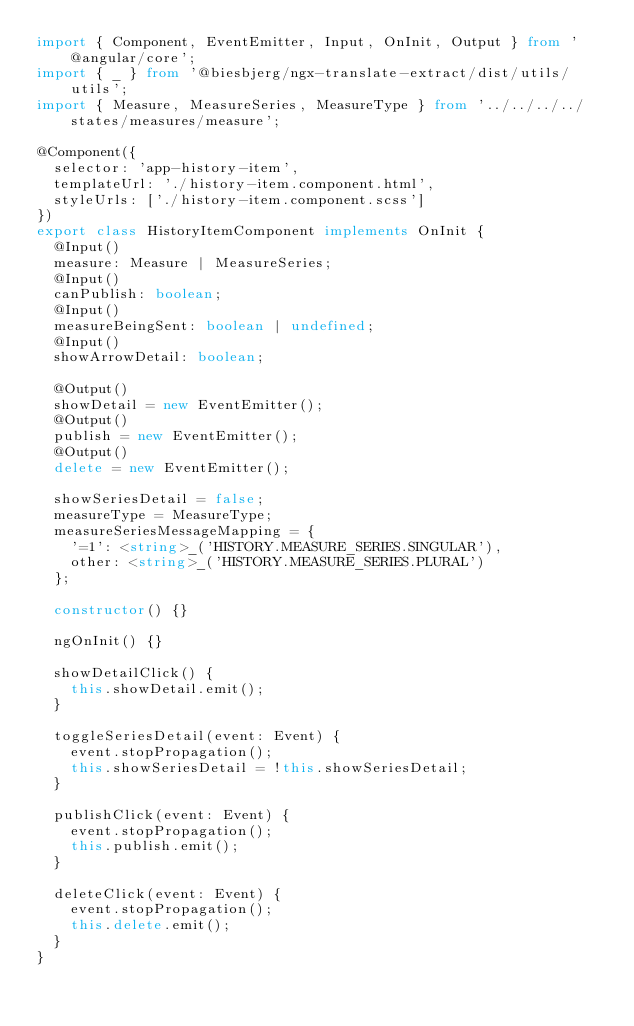<code> <loc_0><loc_0><loc_500><loc_500><_TypeScript_>import { Component, EventEmitter, Input, OnInit, Output } from '@angular/core';
import { _ } from '@biesbjerg/ngx-translate-extract/dist/utils/utils';
import { Measure, MeasureSeries, MeasureType } from '../../../../states/measures/measure';

@Component({
  selector: 'app-history-item',
  templateUrl: './history-item.component.html',
  styleUrls: ['./history-item.component.scss']
})
export class HistoryItemComponent implements OnInit {
  @Input()
  measure: Measure | MeasureSeries;
  @Input()
  canPublish: boolean;
  @Input()
  measureBeingSent: boolean | undefined;
  @Input()
  showArrowDetail: boolean;

  @Output()
  showDetail = new EventEmitter();
  @Output()
  publish = new EventEmitter();
  @Output()
  delete = new EventEmitter();

  showSeriesDetail = false;
  measureType = MeasureType;
  measureSeriesMessageMapping = {
    '=1': <string>_('HISTORY.MEASURE_SERIES.SINGULAR'),
    other: <string>_('HISTORY.MEASURE_SERIES.PLURAL')
  };

  constructor() {}

  ngOnInit() {}

  showDetailClick() {
    this.showDetail.emit();
  }

  toggleSeriesDetail(event: Event) {
    event.stopPropagation();
    this.showSeriesDetail = !this.showSeriesDetail;
  }

  publishClick(event: Event) {
    event.stopPropagation();
    this.publish.emit();
  }

  deleteClick(event: Event) {
    event.stopPropagation();
    this.delete.emit();
  }
}
</code> 